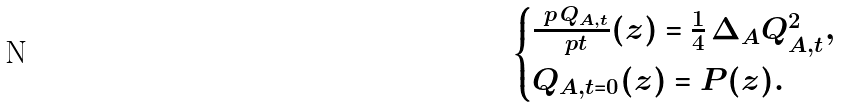Convert formula to latex. <formula><loc_0><loc_0><loc_500><loc_500>\begin{cases} \frac { \ p \, Q _ { A , t } } { \ p t } ( z ) = \frac { 1 } { 4 } \, \Delta _ { A } Q _ { A , t } ^ { 2 } , \\ Q _ { A , t = 0 } ( z ) = P ( z ) . \end{cases}</formula> 